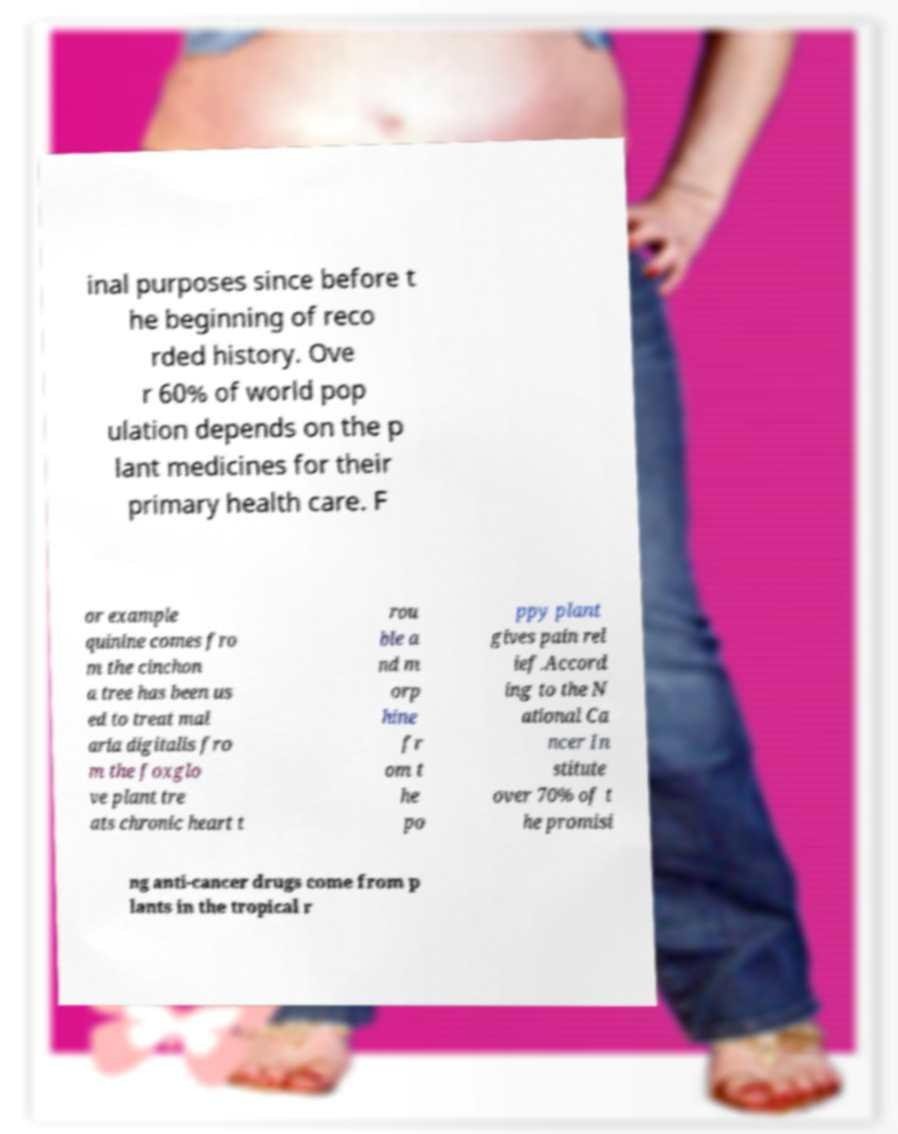For documentation purposes, I need the text within this image transcribed. Could you provide that? inal purposes since before t he beginning of reco rded history. Ove r 60% of world pop ulation depends on the p lant medicines for their primary health care. F or example quinine comes fro m the cinchon a tree has been us ed to treat mal aria digitalis fro m the foxglo ve plant tre ats chronic heart t rou ble a nd m orp hine fr om t he po ppy plant gives pain rel ief.Accord ing to the N ational Ca ncer In stitute over 70% of t he promisi ng anti-cancer drugs come from p lants in the tropical r 